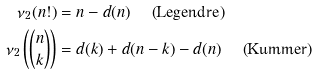Convert formula to latex. <formula><loc_0><loc_0><loc_500><loc_500>\nu _ { 2 } ( n ! ) & = n - d ( n ) \quad \text { (Legendre)} \\ \nu _ { 2 } \left ( \binom { n } { k } \right ) & = d ( k ) + d ( n - k ) - d ( n ) \quad \text { (Kummer)} \\</formula> 